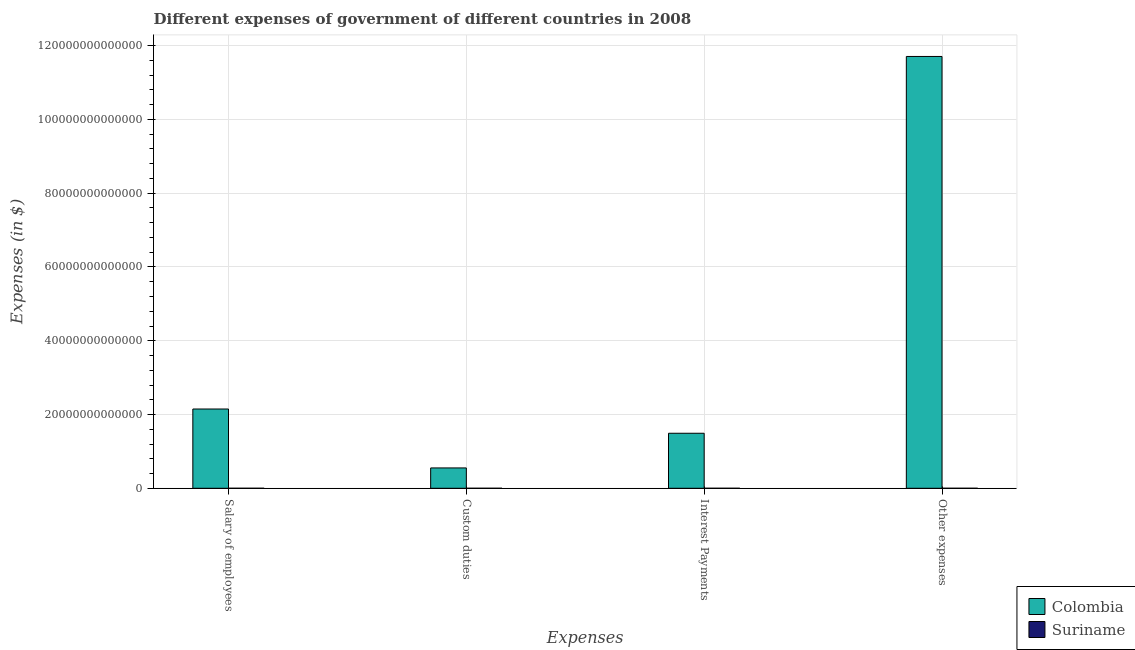How many different coloured bars are there?
Provide a short and direct response. 2. How many groups of bars are there?
Ensure brevity in your answer.  4. Are the number of bars on each tick of the X-axis equal?
Ensure brevity in your answer.  Yes. How many bars are there on the 3rd tick from the right?
Offer a terse response. 2. What is the label of the 1st group of bars from the left?
Offer a terse response. Salary of employees. What is the amount spent on custom duties in Suriname?
Provide a short and direct response. 2.22e+08. Across all countries, what is the maximum amount spent on custom duties?
Your response must be concise. 5.52e+12. Across all countries, what is the minimum amount spent on other expenses?
Ensure brevity in your answer.  1.99e+09. In which country was the amount spent on interest payments minimum?
Ensure brevity in your answer.  Suriname. What is the total amount spent on interest payments in the graph?
Your answer should be very brief. 1.49e+13. What is the difference between the amount spent on custom duties in Suriname and that in Colombia?
Your answer should be very brief. -5.52e+12. What is the difference between the amount spent on custom duties in Suriname and the amount spent on other expenses in Colombia?
Make the answer very short. -1.17e+14. What is the average amount spent on custom duties per country?
Offer a terse response. 2.76e+12. What is the difference between the amount spent on custom duties and amount spent on salary of employees in Colombia?
Ensure brevity in your answer.  -1.60e+13. In how many countries, is the amount spent on salary of employees greater than 16000000000000 $?
Keep it short and to the point. 1. What is the ratio of the amount spent on interest payments in Suriname to that in Colombia?
Offer a very short reply. 4.131900022160812e-6. Is the amount spent on other expenses in Suriname less than that in Colombia?
Make the answer very short. Yes. What is the difference between the highest and the second highest amount spent on interest payments?
Your response must be concise. 1.49e+13. What is the difference between the highest and the lowest amount spent on other expenses?
Keep it short and to the point. 1.17e+14. In how many countries, is the amount spent on other expenses greater than the average amount spent on other expenses taken over all countries?
Make the answer very short. 1. What does the 2nd bar from the right in Other expenses represents?
Offer a terse response. Colombia. Is it the case that in every country, the sum of the amount spent on salary of employees and amount spent on custom duties is greater than the amount spent on interest payments?
Provide a succinct answer. Yes. Are all the bars in the graph horizontal?
Ensure brevity in your answer.  No. What is the difference between two consecutive major ticks on the Y-axis?
Keep it short and to the point. 2.00e+13. Are the values on the major ticks of Y-axis written in scientific E-notation?
Provide a succinct answer. No. Does the graph contain any zero values?
Offer a terse response. No. Where does the legend appear in the graph?
Give a very brief answer. Bottom right. How many legend labels are there?
Keep it short and to the point. 2. What is the title of the graph?
Your response must be concise. Different expenses of government of different countries in 2008. Does "Suriname" appear as one of the legend labels in the graph?
Give a very brief answer. Yes. What is the label or title of the X-axis?
Offer a terse response. Expenses. What is the label or title of the Y-axis?
Provide a succinct answer. Expenses (in $). What is the Expenses (in $) of Colombia in Salary of employees?
Make the answer very short. 2.15e+13. What is the Expenses (in $) in Suriname in Salary of employees?
Provide a short and direct response. 7.59e+08. What is the Expenses (in $) of Colombia in Custom duties?
Give a very brief answer. 5.52e+12. What is the Expenses (in $) in Suriname in Custom duties?
Your response must be concise. 2.22e+08. What is the Expenses (in $) in Colombia in Interest Payments?
Offer a terse response. 1.49e+13. What is the Expenses (in $) in Suriname in Interest Payments?
Offer a very short reply. 6.16e+07. What is the Expenses (in $) in Colombia in Other expenses?
Make the answer very short. 1.17e+14. What is the Expenses (in $) in Suriname in Other expenses?
Offer a very short reply. 1.99e+09. Across all Expenses, what is the maximum Expenses (in $) in Colombia?
Your answer should be very brief. 1.17e+14. Across all Expenses, what is the maximum Expenses (in $) in Suriname?
Give a very brief answer. 1.99e+09. Across all Expenses, what is the minimum Expenses (in $) in Colombia?
Your response must be concise. 5.52e+12. Across all Expenses, what is the minimum Expenses (in $) of Suriname?
Provide a short and direct response. 6.16e+07. What is the total Expenses (in $) of Colombia in the graph?
Offer a very short reply. 1.59e+14. What is the total Expenses (in $) of Suriname in the graph?
Your answer should be very brief. 3.03e+09. What is the difference between the Expenses (in $) in Colombia in Salary of employees and that in Custom duties?
Your answer should be compact. 1.60e+13. What is the difference between the Expenses (in $) in Suriname in Salary of employees and that in Custom duties?
Offer a terse response. 5.37e+08. What is the difference between the Expenses (in $) in Colombia in Salary of employees and that in Interest Payments?
Provide a succinct answer. 6.58e+12. What is the difference between the Expenses (in $) of Suriname in Salary of employees and that in Interest Payments?
Offer a terse response. 6.97e+08. What is the difference between the Expenses (in $) in Colombia in Salary of employees and that in Other expenses?
Provide a short and direct response. -9.56e+13. What is the difference between the Expenses (in $) in Suriname in Salary of employees and that in Other expenses?
Offer a terse response. -1.23e+09. What is the difference between the Expenses (in $) of Colombia in Custom duties and that in Interest Payments?
Your answer should be very brief. -9.40e+12. What is the difference between the Expenses (in $) in Suriname in Custom duties and that in Interest Payments?
Provide a succinct answer. 1.60e+08. What is the difference between the Expenses (in $) of Colombia in Custom duties and that in Other expenses?
Offer a terse response. -1.12e+14. What is the difference between the Expenses (in $) of Suriname in Custom duties and that in Other expenses?
Ensure brevity in your answer.  -1.77e+09. What is the difference between the Expenses (in $) in Colombia in Interest Payments and that in Other expenses?
Ensure brevity in your answer.  -1.02e+14. What is the difference between the Expenses (in $) in Suriname in Interest Payments and that in Other expenses?
Give a very brief answer. -1.93e+09. What is the difference between the Expenses (in $) of Colombia in Salary of employees and the Expenses (in $) of Suriname in Custom duties?
Provide a short and direct response. 2.15e+13. What is the difference between the Expenses (in $) of Colombia in Salary of employees and the Expenses (in $) of Suriname in Interest Payments?
Your answer should be very brief. 2.15e+13. What is the difference between the Expenses (in $) of Colombia in Salary of employees and the Expenses (in $) of Suriname in Other expenses?
Offer a terse response. 2.15e+13. What is the difference between the Expenses (in $) of Colombia in Custom duties and the Expenses (in $) of Suriname in Interest Payments?
Provide a short and direct response. 5.52e+12. What is the difference between the Expenses (in $) of Colombia in Custom duties and the Expenses (in $) of Suriname in Other expenses?
Offer a terse response. 5.51e+12. What is the difference between the Expenses (in $) in Colombia in Interest Payments and the Expenses (in $) in Suriname in Other expenses?
Your response must be concise. 1.49e+13. What is the average Expenses (in $) in Colombia per Expenses?
Your answer should be very brief. 3.98e+13. What is the average Expenses (in $) of Suriname per Expenses?
Offer a terse response. 7.57e+08. What is the difference between the Expenses (in $) in Colombia and Expenses (in $) in Suriname in Salary of employees?
Provide a succinct answer. 2.15e+13. What is the difference between the Expenses (in $) in Colombia and Expenses (in $) in Suriname in Custom duties?
Your response must be concise. 5.52e+12. What is the difference between the Expenses (in $) in Colombia and Expenses (in $) in Suriname in Interest Payments?
Your response must be concise. 1.49e+13. What is the difference between the Expenses (in $) of Colombia and Expenses (in $) of Suriname in Other expenses?
Offer a terse response. 1.17e+14. What is the ratio of the Expenses (in $) of Colombia in Salary of employees to that in Custom duties?
Give a very brief answer. 3.9. What is the ratio of the Expenses (in $) in Suriname in Salary of employees to that in Custom duties?
Offer a very short reply. 3.42. What is the ratio of the Expenses (in $) in Colombia in Salary of employees to that in Interest Payments?
Your answer should be very brief. 1.44. What is the ratio of the Expenses (in $) of Suriname in Salary of employees to that in Interest Payments?
Give a very brief answer. 12.31. What is the ratio of the Expenses (in $) in Colombia in Salary of employees to that in Other expenses?
Offer a very short reply. 0.18. What is the ratio of the Expenses (in $) of Suriname in Salary of employees to that in Other expenses?
Provide a short and direct response. 0.38. What is the ratio of the Expenses (in $) in Colombia in Custom duties to that in Interest Payments?
Your response must be concise. 0.37. What is the ratio of the Expenses (in $) in Colombia in Custom duties to that in Other expenses?
Your answer should be very brief. 0.05. What is the ratio of the Expenses (in $) in Suriname in Custom duties to that in Other expenses?
Keep it short and to the point. 0.11. What is the ratio of the Expenses (in $) of Colombia in Interest Payments to that in Other expenses?
Keep it short and to the point. 0.13. What is the ratio of the Expenses (in $) of Suriname in Interest Payments to that in Other expenses?
Offer a very short reply. 0.03. What is the difference between the highest and the second highest Expenses (in $) of Colombia?
Your answer should be compact. 9.56e+13. What is the difference between the highest and the second highest Expenses (in $) of Suriname?
Provide a short and direct response. 1.23e+09. What is the difference between the highest and the lowest Expenses (in $) in Colombia?
Ensure brevity in your answer.  1.12e+14. What is the difference between the highest and the lowest Expenses (in $) of Suriname?
Your response must be concise. 1.93e+09. 